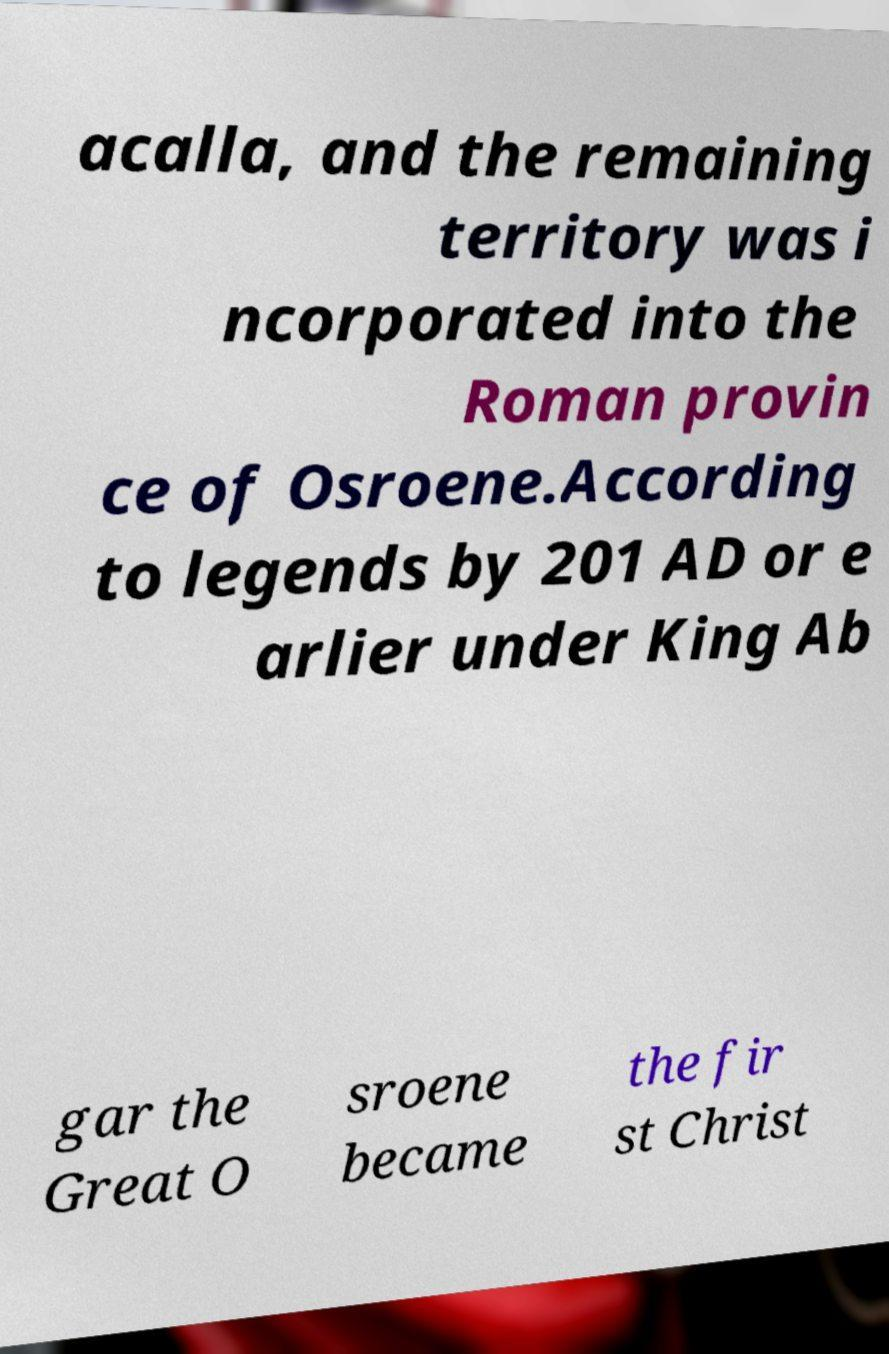Could you assist in decoding the text presented in this image and type it out clearly? acalla, and the remaining territory was i ncorporated into the Roman provin ce of Osroene.According to legends by 201 AD or e arlier under King Ab gar the Great O sroene became the fir st Christ 